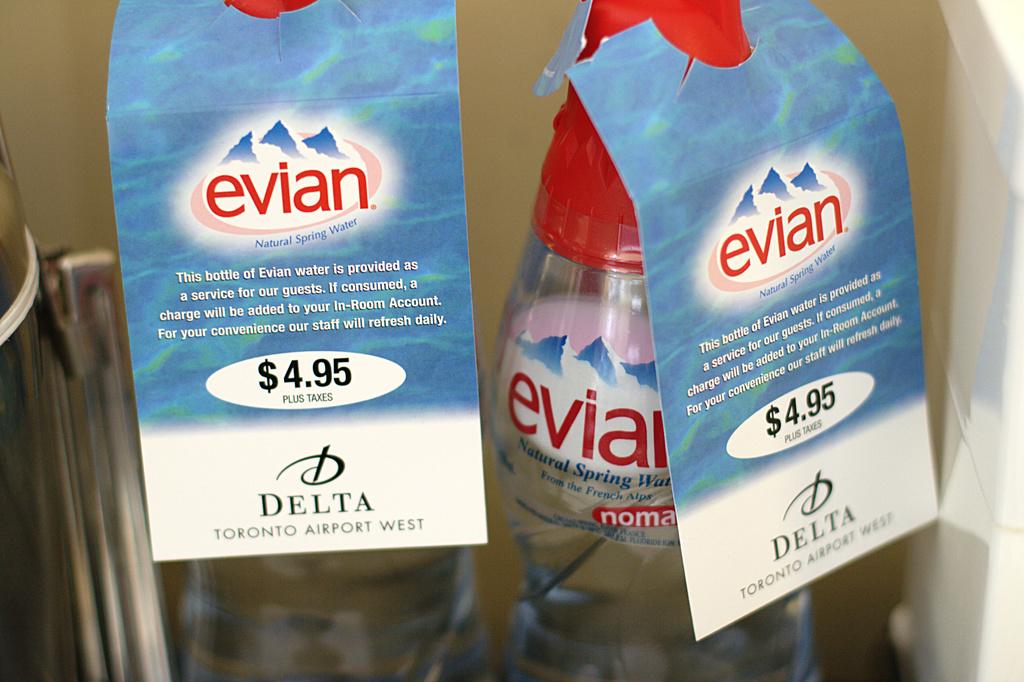What is the price of the bottle of water?
Offer a very short reply. 4.95. What is the brand of water?
Your answer should be very brief. Evian. 